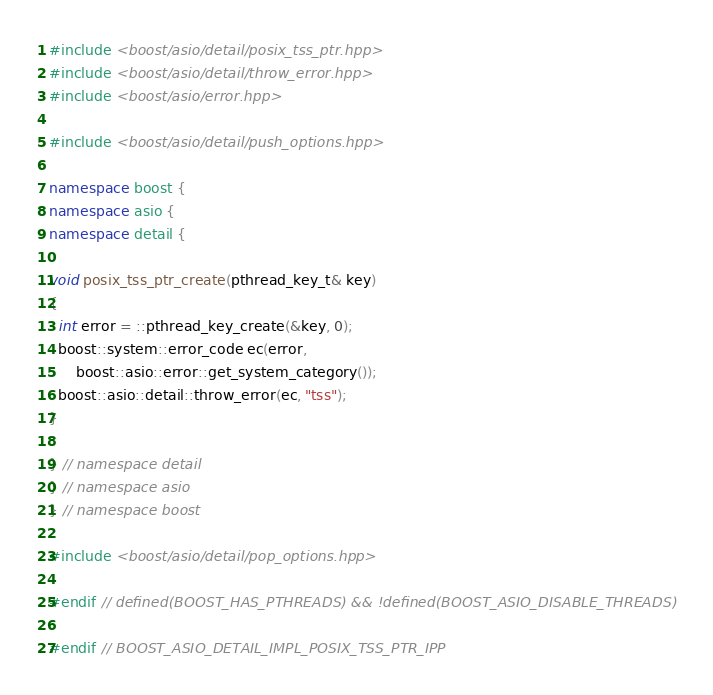<code> <loc_0><loc_0><loc_500><loc_500><_C++_>
#include <boost/asio/detail/posix_tss_ptr.hpp>
#include <boost/asio/detail/throw_error.hpp>
#include <boost/asio/error.hpp>

#include <boost/asio/detail/push_options.hpp>

namespace boost {
namespace asio {
namespace detail {

void posix_tss_ptr_create(pthread_key_t& key)
{
  int error = ::pthread_key_create(&key, 0);
  boost::system::error_code ec(error,
      boost::asio::error::get_system_category());
  boost::asio::detail::throw_error(ec, "tss");
}

} // namespace detail
} // namespace asio
} // namespace boost

#include <boost/asio/detail/pop_options.hpp>

#endif // defined(BOOST_HAS_PTHREADS) && !defined(BOOST_ASIO_DISABLE_THREADS)

#endif // BOOST_ASIO_DETAIL_IMPL_POSIX_TSS_PTR_IPP
</code> 